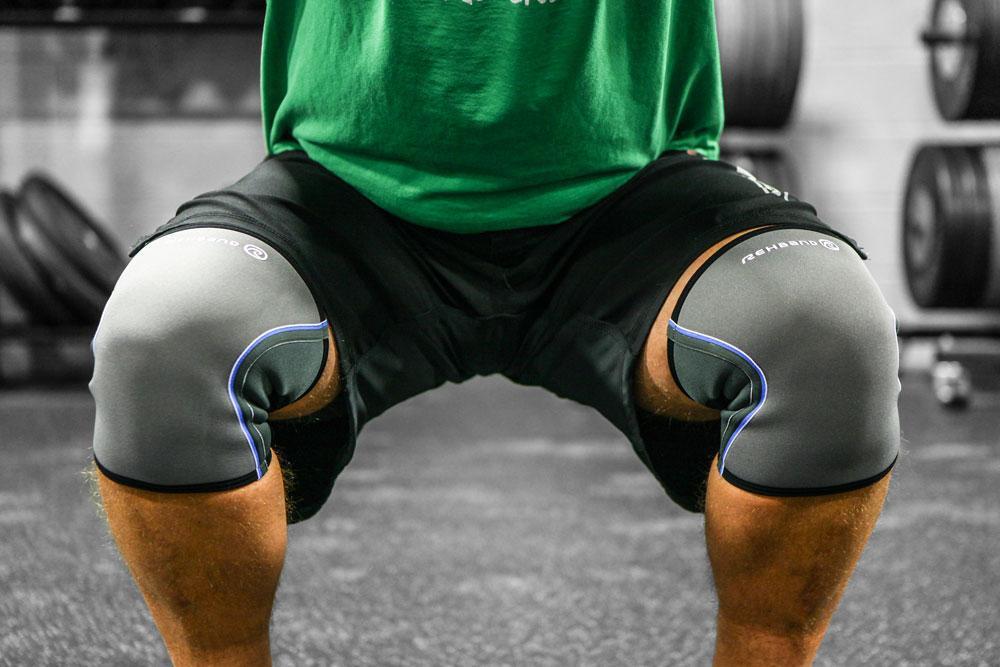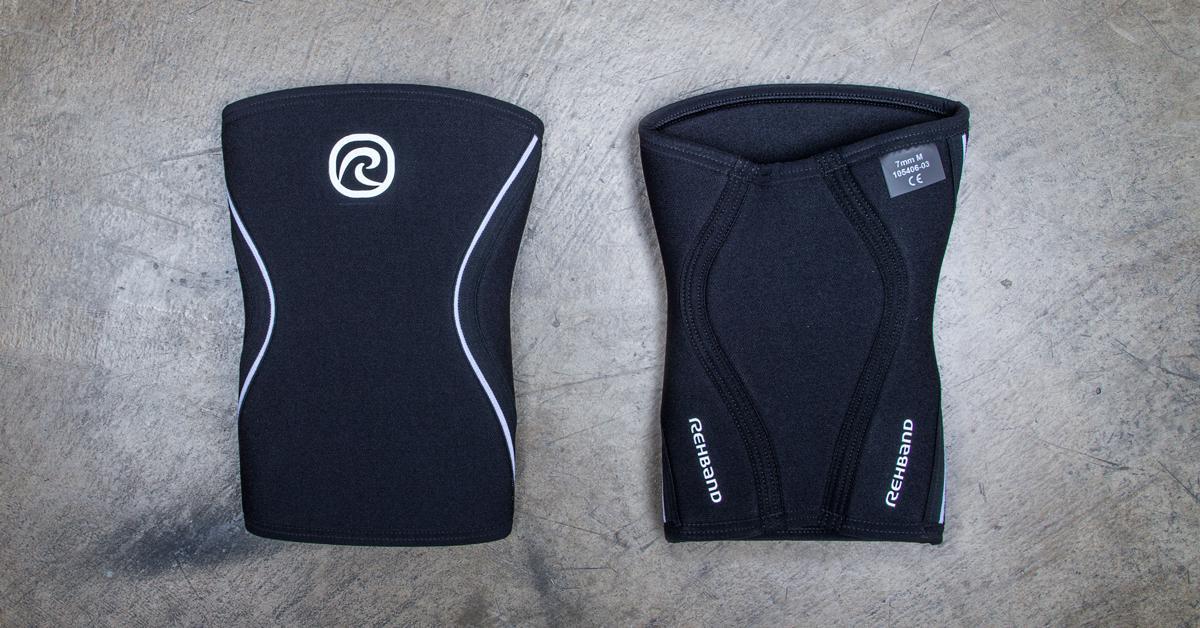The first image is the image on the left, the second image is the image on the right. Evaluate the accuracy of this statement regarding the images: "No one is wearing the pads in the image on the right.". Is it true? Answer yes or no. Yes. 